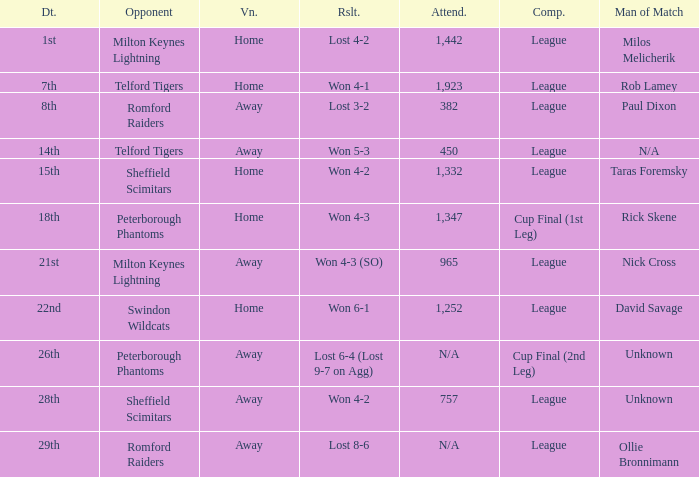What was the date when the opponent was Sheffield Scimitars and the venue was Home? 15th. 